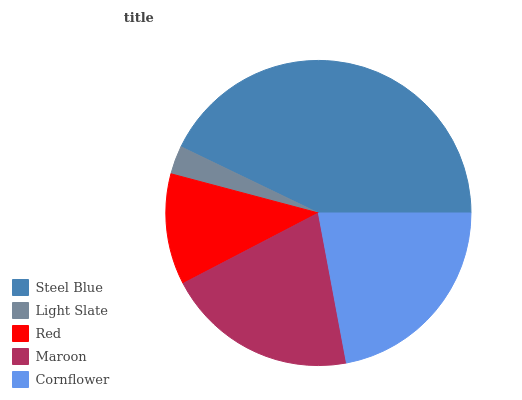Is Light Slate the minimum?
Answer yes or no. Yes. Is Steel Blue the maximum?
Answer yes or no. Yes. Is Red the minimum?
Answer yes or no. No. Is Red the maximum?
Answer yes or no. No. Is Red greater than Light Slate?
Answer yes or no. Yes. Is Light Slate less than Red?
Answer yes or no. Yes. Is Light Slate greater than Red?
Answer yes or no. No. Is Red less than Light Slate?
Answer yes or no. No. Is Maroon the high median?
Answer yes or no. Yes. Is Maroon the low median?
Answer yes or no. Yes. Is Cornflower the high median?
Answer yes or no. No. Is Cornflower the low median?
Answer yes or no. No. 